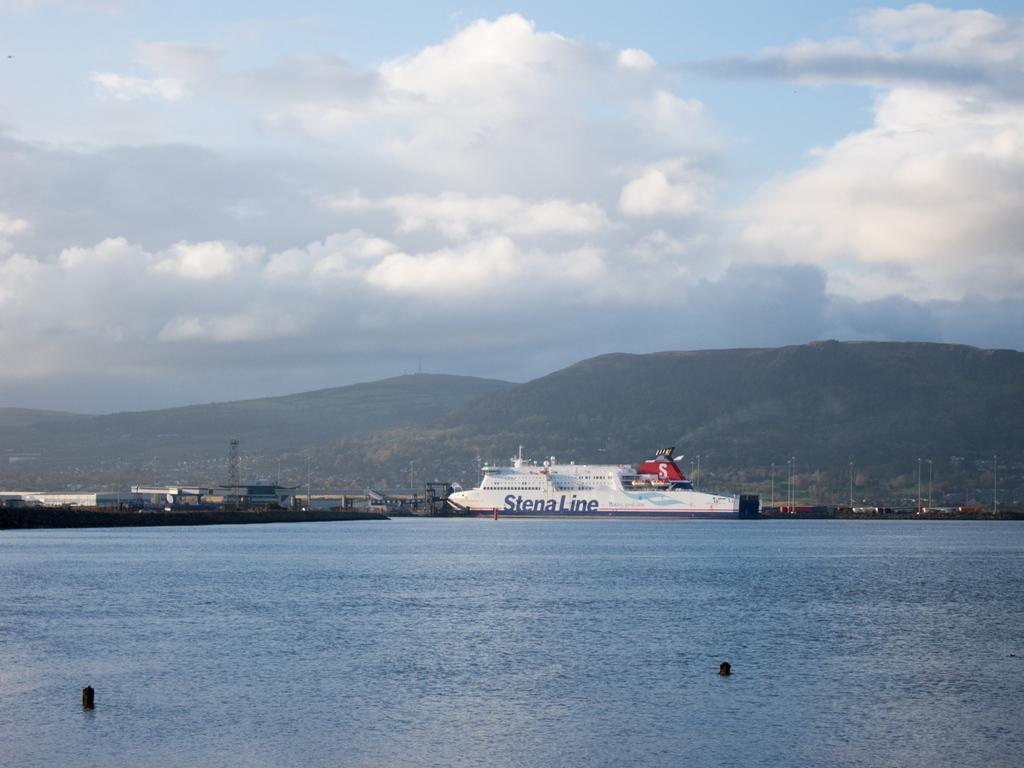In one or two sentences, can you explain what this image depicts? In this picture we can see objects, ship and water. In the background of the image we can see buildings, poles, hills and sky with clouds. 